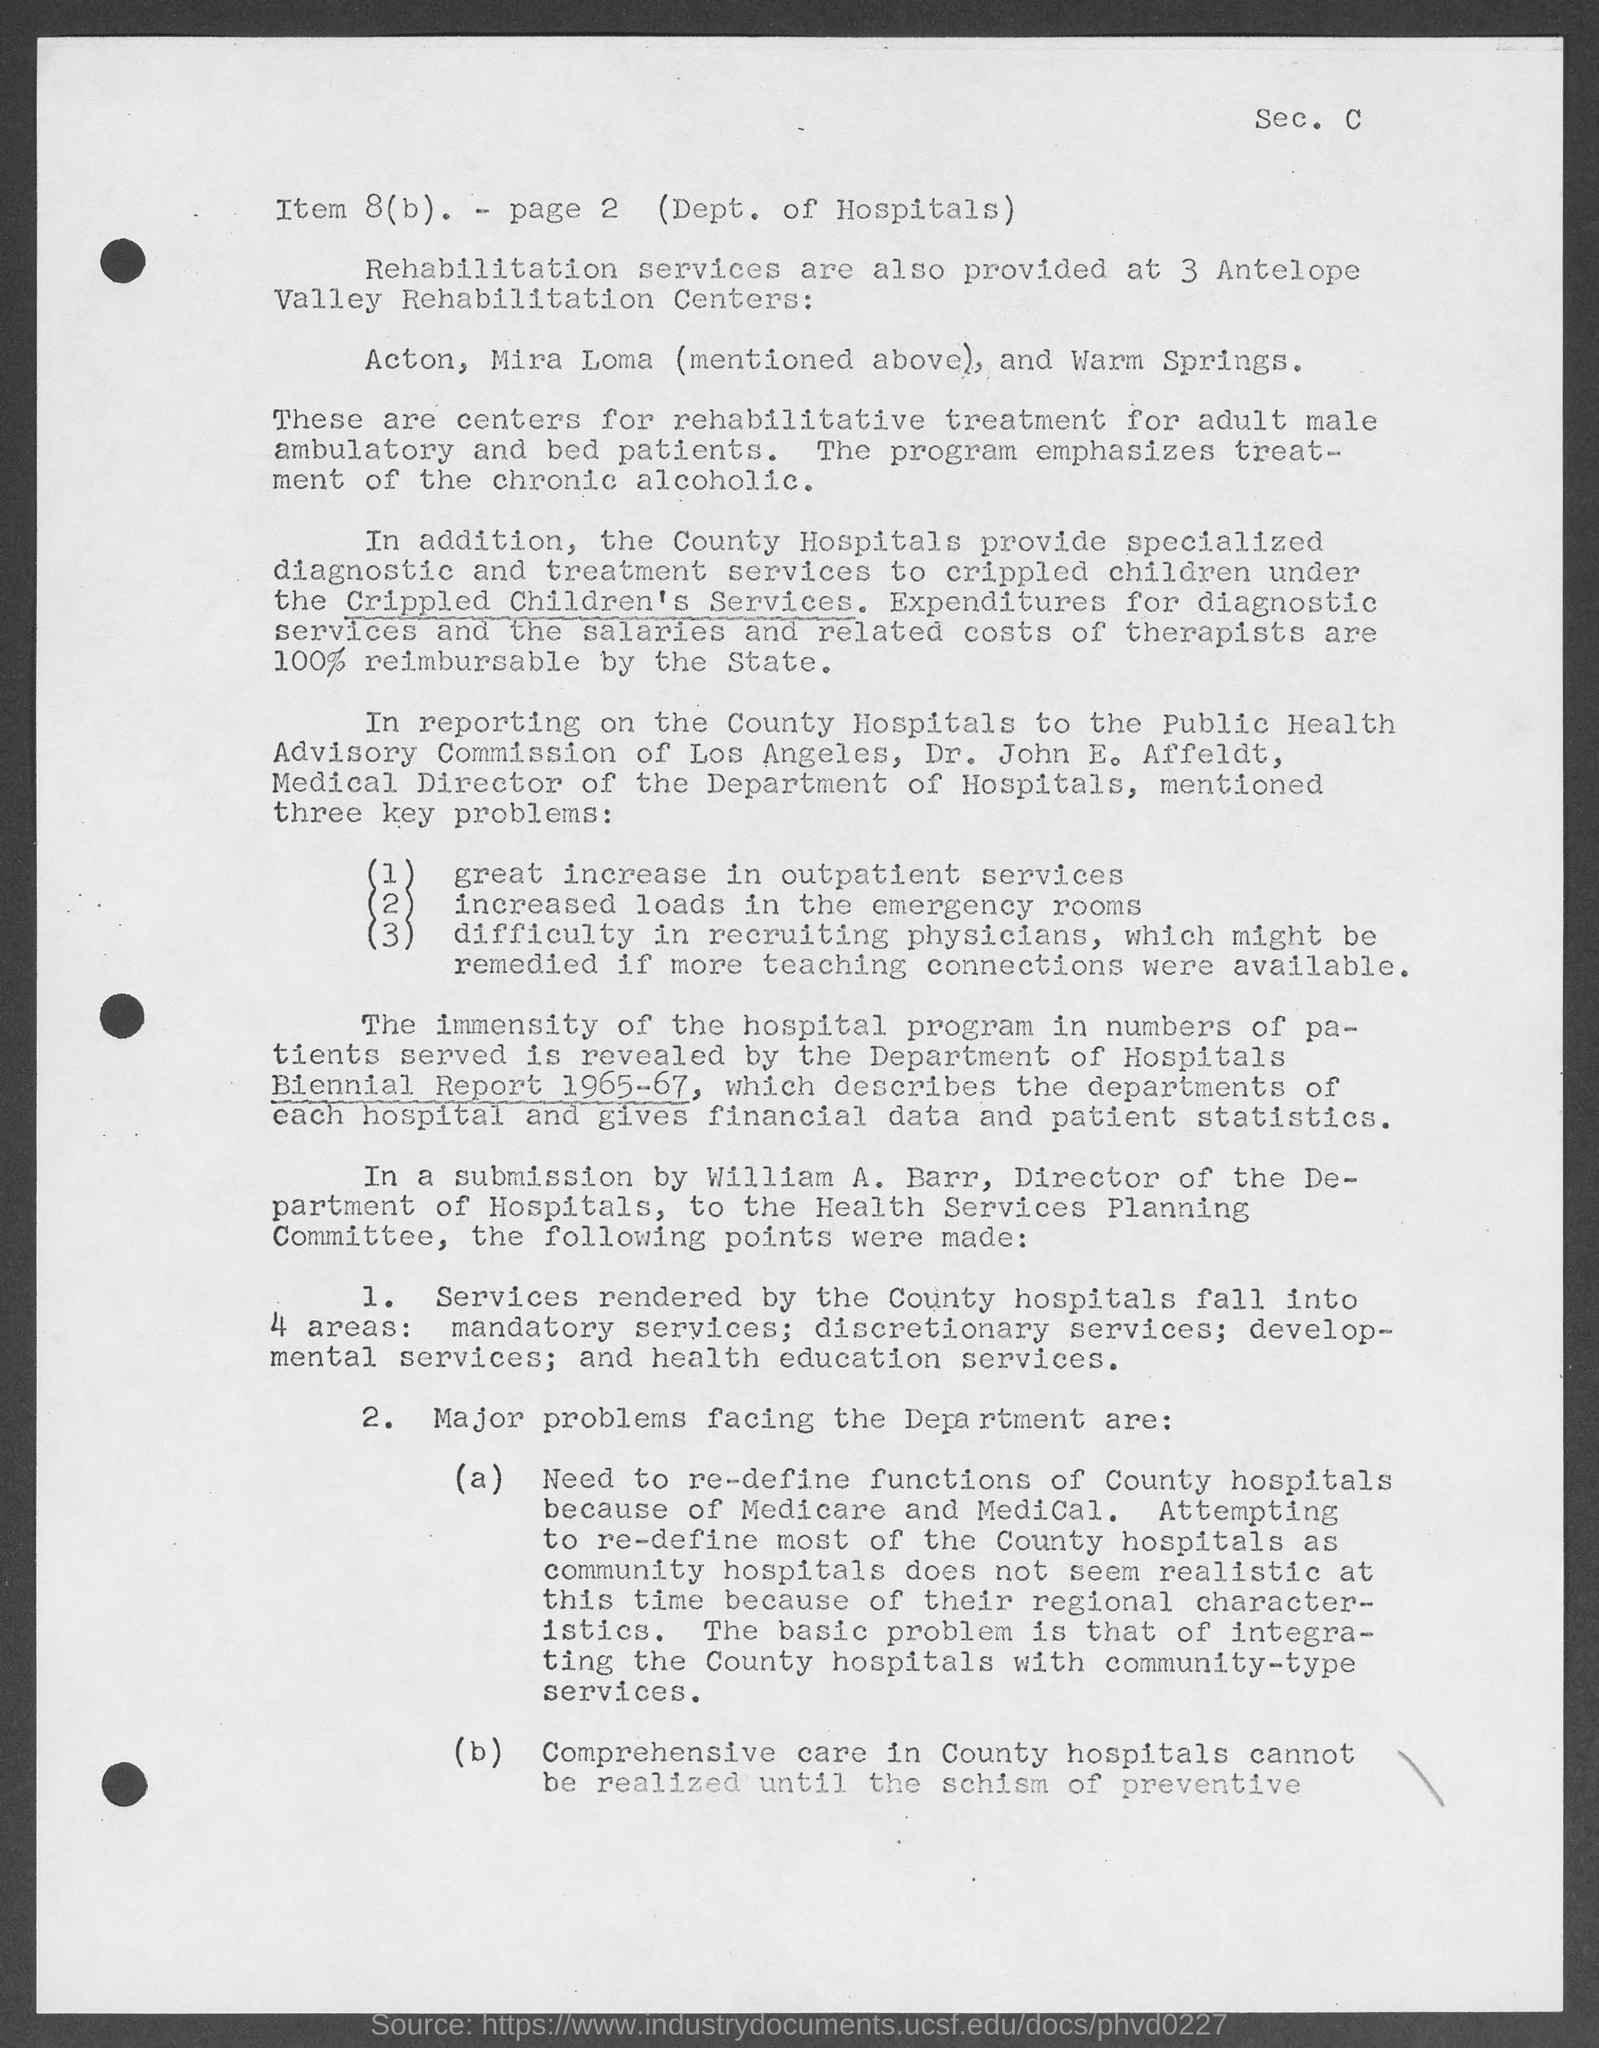What is written on the top-right of the document?
Ensure brevity in your answer.  Sec. C. 